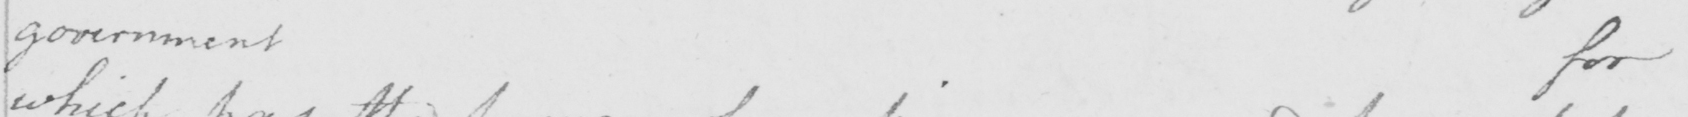Please provide the text content of this handwritten line. government for 